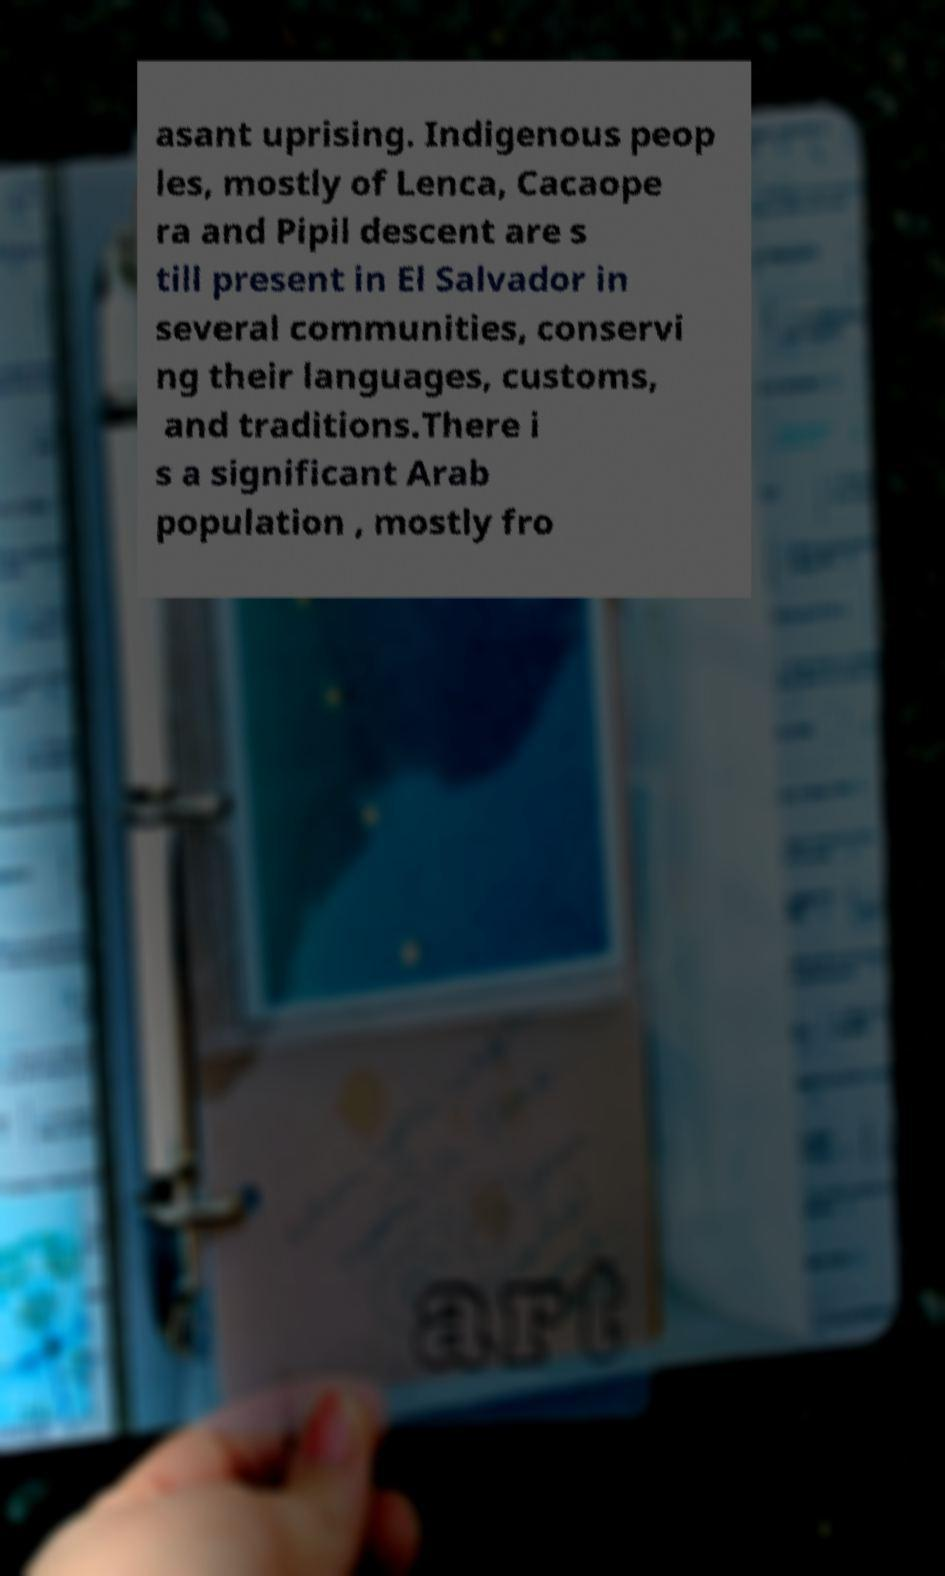For documentation purposes, I need the text within this image transcribed. Could you provide that? asant uprising. Indigenous peop les, mostly of Lenca, Cacaope ra and Pipil descent are s till present in El Salvador in several communities, conservi ng their languages, customs, and traditions.There i s a significant Arab population , mostly fro 